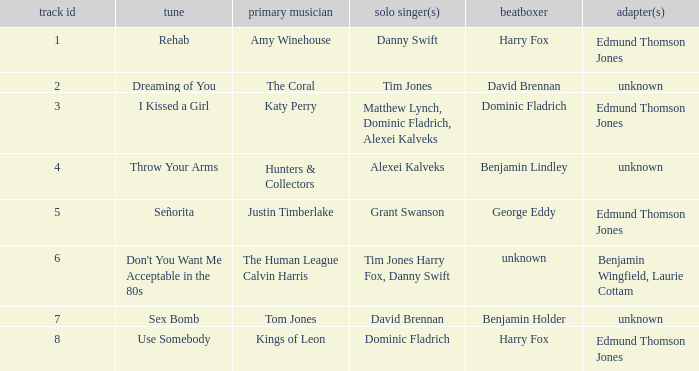Who is the arranger for "I KIssed a Girl"? Edmund Thomson Jones. 